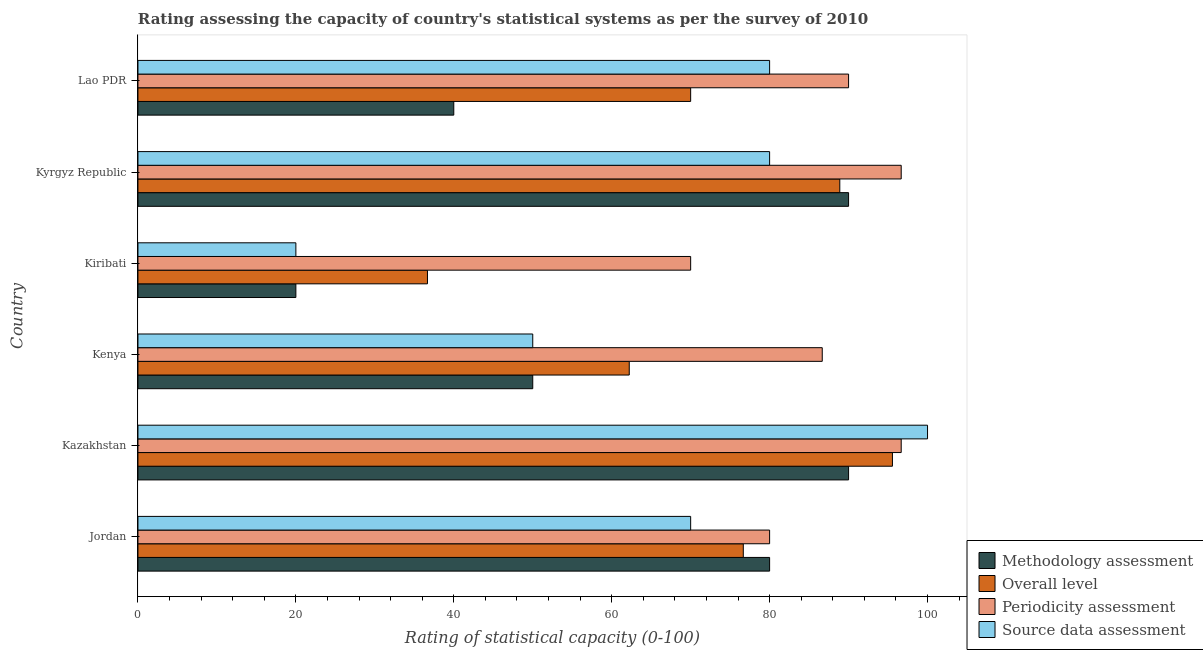How many groups of bars are there?
Give a very brief answer. 6. Are the number of bars per tick equal to the number of legend labels?
Your response must be concise. Yes. Are the number of bars on each tick of the Y-axis equal?
Provide a short and direct response. Yes. How many bars are there on the 6th tick from the bottom?
Your response must be concise. 4. What is the label of the 4th group of bars from the top?
Provide a short and direct response. Kenya. In how many cases, is the number of bars for a given country not equal to the number of legend labels?
Provide a succinct answer. 0. What is the overall level rating in Kenya?
Offer a very short reply. 62.22. Across all countries, what is the maximum overall level rating?
Your answer should be very brief. 95.56. Across all countries, what is the minimum methodology assessment rating?
Provide a succinct answer. 20. In which country was the methodology assessment rating maximum?
Your response must be concise. Kazakhstan. In which country was the source data assessment rating minimum?
Offer a terse response. Kiribati. What is the total periodicity assessment rating in the graph?
Offer a terse response. 520. What is the difference between the periodicity assessment rating in Kiribati and that in Kyrgyz Republic?
Make the answer very short. -26.67. What is the difference between the periodicity assessment rating in Kenya and the source data assessment rating in Kiribati?
Make the answer very short. 66.67. What is the average periodicity assessment rating per country?
Ensure brevity in your answer.  86.67. In how many countries, is the methodology assessment rating greater than 68 ?
Provide a succinct answer. 3. What is the ratio of the methodology assessment rating in Jordan to that in Lao PDR?
Keep it short and to the point. 2. Is the source data assessment rating in Kiribati less than that in Lao PDR?
Offer a terse response. Yes. Is the difference between the source data assessment rating in Jordan and Kiribati greater than the difference between the periodicity assessment rating in Jordan and Kiribati?
Ensure brevity in your answer.  Yes. What is the difference between the highest and the second highest methodology assessment rating?
Give a very brief answer. 0. What is the difference between the highest and the lowest methodology assessment rating?
Your response must be concise. 70. In how many countries, is the methodology assessment rating greater than the average methodology assessment rating taken over all countries?
Make the answer very short. 3. Is it the case that in every country, the sum of the methodology assessment rating and source data assessment rating is greater than the sum of periodicity assessment rating and overall level rating?
Provide a succinct answer. No. What does the 4th bar from the top in Kazakhstan represents?
Your response must be concise. Methodology assessment. What does the 4th bar from the bottom in Kenya represents?
Make the answer very short. Source data assessment. Is it the case that in every country, the sum of the methodology assessment rating and overall level rating is greater than the periodicity assessment rating?
Keep it short and to the point. No. How many bars are there?
Your answer should be very brief. 24. Are all the bars in the graph horizontal?
Offer a very short reply. Yes. How many countries are there in the graph?
Provide a short and direct response. 6. Where does the legend appear in the graph?
Offer a terse response. Bottom right. How many legend labels are there?
Provide a short and direct response. 4. How are the legend labels stacked?
Give a very brief answer. Vertical. What is the title of the graph?
Keep it short and to the point. Rating assessing the capacity of country's statistical systems as per the survey of 2010 . Does "Primary schools" appear as one of the legend labels in the graph?
Provide a succinct answer. No. What is the label or title of the X-axis?
Give a very brief answer. Rating of statistical capacity (0-100). What is the label or title of the Y-axis?
Your answer should be compact. Country. What is the Rating of statistical capacity (0-100) in Methodology assessment in Jordan?
Provide a succinct answer. 80. What is the Rating of statistical capacity (0-100) in Overall level in Jordan?
Your answer should be compact. 76.67. What is the Rating of statistical capacity (0-100) in Periodicity assessment in Jordan?
Keep it short and to the point. 80. What is the Rating of statistical capacity (0-100) in Source data assessment in Jordan?
Provide a short and direct response. 70. What is the Rating of statistical capacity (0-100) in Methodology assessment in Kazakhstan?
Offer a very short reply. 90. What is the Rating of statistical capacity (0-100) in Overall level in Kazakhstan?
Keep it short and to the point. 95.56. What is the Rating of statistical capacity (0-100) of Periodicity assessment in Kazakhstan?
Give a very brief answer. 96.67. What is the Rating of statistical capacity (0-100) in Overall level in Kenya?
Give a very brief answer. 62.22. What is the Rating of statistical capacity (0-100) of Periodicity assessment in Kenya?
Provide a succinct answer. 86.67. What is the Rating of statistical capacity (0-100) of Overall level in Kiribati?
Ensure brevity in your answer.  36.67. What is the Rating of statistical capacity (0-100) in Periodicity assessment in Kiribati?
Provide a succinct answer. 70. What is the Rating of statistical capacity (0-100) in Methodology assessment in Kyrgyz Republic?
Keep it short and to the point. 90. What is the Rating of statistical capacity (0-100) in Overall level in Kyrgyz Republic?
Offer a terse response. 88.89. What is the Rating of statistical capacity (0-100) of Periodicity assessment in Kyrgyz Republic?
Make the answer very short. 96.67. What is the Rating of statistical capacity (0-100) of Overall level in Lao PDR?
Make the answer very short. 70. What is the Rating of statistical capacity (0-100) in Periodicity assessment in Lao PDR?
Offer a terse response. 90. Across all countries, what is the maximum Rating of statistical capacity (0-100) of Methodology assessment?
Your answer should be compact. 90. Across all countries, what is the maximum Rating of statistical capacity (0-100) of Overall level?
Offer a terse response. 95.56. Across all countries, what is the maximum Rating of statistical capacity (0-100) of Periodicity assessment?
Give a very brief answer. 96.67. Across all countries, what is the maximum Rating of statistical capacity (0-100) in Source data assessment?
Keep it short and to the point. 100. Across all countries, what is the minimum Rating of statistical capacity (0-100) in Overall level?
Ensure brevity in your answer.  36.67. Across all countries, what is the minimum Rating of statistical capacity (0-100) of Source data assessment?
Your answer should be compact. 20. What is the total Rating of statistical capacity (0-100) of Methodology assessment in the graph?
Make the answer very short. 370. What is the total Rating of statistical capacity (0-100) of Overall level in the graph?
Your response must be concise. 430. What is the total Rating of statistical capacity (0-100) in Periodicity assessment in the graph?
Offer a very short reply. 520. What is the total Rating of statistical capacity (0-100) of Source data assessment in the graph?
Give a very brief answer. 400. What is the difference between the Rating of statistical capacity (0-100) in Overall level in Jordan and that in Kazakhstan?
Provide a short and direct response. -18.89. What is the difference between the Rating of statistical capacity (0-100) of Periodicity assessment in Jordan and that in Kazakhstan?
Provide a short and direct response. -16.67. What is the difference between the Rating of statistical capacity (0-100) of Source data assessment in Jordan and that in Kazakhstan?
Provide a succinct answer. -30. What is the difference between the Rating of statistical capacity (0-100) in Overall level in Jordan and that in Kenya?
Keep it short and to the point. 14.44. What is the difference between the Rating of statistical capacity (0-100) of Periodicity assessment in Jordan and that in Kenya?
Your answer should be very brief. -6.67. What is the difference between the Rating of statistical capacity (0-100) in Source data assessment in Jordan and that in Kenya?
Offer a very short reply. 20. What is the difference between the Rating of statistical capacity (0-100) in Overall level in Jordan and that in Kyrgyz Republic?
Provide a short and direct response. -12.22. What is the difference between the Rating of statistical capacity (0-100) in Periodicity assessment in Jordan and that in Kyrgyz Republic?
Your answer should be very brief. -16.67. What is the difference between the Rating of statistical capacity (0-100) in Source data assessment in Jordan and that in Kyrgyz Republic?
Ensure brevity in your answer.  -10. What is the difference between the Rating of statistical capacity (0-100) of Source data assessment in Jordan and that in Lao PDR?
Your answer should be compact. -10. What is the difference between the Rating of statistical capacity (0-100) in Overall level in Kazakhstan and that in Kenya?
Your response must be concise. 33.33. What is the difference between the Rating of statistical capacity (0-100) in Overall level in Kazakhstan and that in Kiribati?
Ensure brevity in your answer.  58.89. What is the difference between the Rating of statistical capacity (0-100) in Periodicity assessment in Kazakhstan and that in Kiribati?
Keep it short and to the point. 26.67. What is the difference between the Rating of statistical capacity (0-100) in Methodology assessment in Kazakhstan and that in Kyrgyz Republic?
Keep it short and to the point. 0. What is the difference between the Rating of statistical capacity (0-100) of Overall level in Kazakhstan and that in Lao PDR?
Your response must be concise. 25.56. What is the difference between the Rating of statistical capacity (0-100) of Source data assessment in Kazakhstan and that in Lao PDR?
Your answer should be very brief. 20. What is the difference between the Rating of statistical capacity (0-100) in Overall level in Kenya and that in Kiribati?
Provide a succinct answer. 25.56. What is the difference between the Rating of statistical capacity (0-100) of Periodicity assessment in Kenya and that in Kiribati?
Offer a terse response. 16.67. What is the difference between the Rating of statistical capacity (0-100) of Overall level in Kenya and that in Kyrgyz Republic?
Your answer should be very brief. -26.67. What is the difference between the Rating of statistical capacity (0-100) of Periodicity assessment in Kenya and that in Kyrgyz Republic?
Your response must be concise. -10. What is the difference between the Rating of statistical capacity (0-100) in Source data assessment in Kenya and that in Kyrgyz Republic?
Offer a very short reply. -30. What is the difference between the Rating of statistical capacity (0-100) in Overall level in Kenya and that in Lao PDR?
Offer a terse response. -7.78. What is the difference between the Rating of statistical capacity (0-100) of Source data assessment in Kenya and that in Lao PDR?
Your answer should be very brief. -30. What is the difference between the Rating of statistical capacity (0-100) in Methodology assessment in Kiribati and that in Kyrgyz Republic?
Provide a succinct answer. -70. What is the difference between the Rating of statistical capacity (0-100) of Overall level in Kiribati and that in Kyrgyz Republic?
Make the answer very short. -52.22. What is the difference between the Rating of statistical capacity (0-100) of Periodicity assessment in Kiribati and that in Kyrgyz Republic?
Provide a succinct answer. -26.67. What is the difference between the Rating of statistical capacity (0-100) in Source data assessment in Kiribati and that in Kyrgyz Republic?
Make the answer very short. -60. What is the difference between the Rating of statistical capacity (0-100) of Methodology assessment in Kiribati and that in Lao PDR?
Provide a short and direct response. -20. What is the difference between the Rating of statistical capacity (0-100) of Overall level in Kiribati and that in Lao PDR?
Make the answer very short. -33.33. What is the difference between the Rating of statistical capacity (0-100) in Source data assessment in Kiribati and that in Lao PDR?
Make the answer very short. -60. What is the difference between the Rating of statistical capacity (0-100) in Methodology assessment in Kyrgyz Republic and that in Lao PDR?
Provide a succinct answer. 50. What is the difference between the Rating of statistical capacity (0-100) of Overall level in Kyrgyz Republic and that in Lao PDR?
Your response must be concise. 18.89. What is the difference between the Rating of statistical capacity (0-100) of Source data assessment in Kyrgyz Republic and that in Lao PDR?
Give a very brief answer. 0. What is the difference between the Rating of statistical capacity (0-100) of Methodology assessment in Jordan and the Rating of statistical capacity (0-100) of Overall level in Kazakhstan?
Ensure brevity in your answer.  -15.56. What is the difference between the Rating of statistical capacity (0-100) in Methodology assessment in Jordan and the Rating of statistical capacity (0-100) in Periodicity assessment in Kazakhstan?
Your response must be concise. -16.67. What is the difference between the Rating of statistical capacity (0-100) in Methodology assessment in Jordan and the Rating of statistical capacity (0-100) in Source data assessment in Kazakhstan?
Keep it short and to the point. -20. What is the difference between the Rating of statistical capacity (0-100) of Overall level in Jordan and the Rating of statistical capacity (0-100) of Source data assessment in Kazakhstan?
Provide a short and direct response. -23.33. What is the difference between the Rating of statistical capacity (0-100) of Periodicity assessment in Jordan and the Rating of statistical capacity (0-100) of Source data assessment in Kazakhstan?
Keep it short and to the point. -20. What is the difference between the Rating of statistical capacity (0-100) in Methodology assessment in Jordan and the Rating of statistical capacity (0-100) in Overall level in Kenya?
Your answer should be very brief. 17.78. What is the difference between the Rating of statistical capacity (0-100) in Methodology assessment in Jordan and the Rating of statistical capacity (0-100) in Periodicity assessment in Kenya?
Your answer should be very brief. -6.67. What is the difference between the Rating of statistical capacity (0-100) in Overall level in Jordan and the Rating of statistical capacity (0-100) in Source data assessment in Kenya?
Your answer should be very brief. 26.67. What is the difference between the Rating of statistical capacity (0-100) of Periodicity assessment in Jordan and the Rating of statistical capacity (0-100) of Source data assessment in Kenya?
Give a very brief answer. 30. What is the difference between the Rating of statistical capacity (0-100) in Methodology assessment in Jordan and the Rating of statistical capacity (0-100) in Overall level in Kiribati?
Offer a very short reply. 43.33. What is the difference between the Rating of statistical capacity (0-100) of Methodology assessment in Jordan and the Rating of statistical capacity (0-100) of Periodicity assessment in Kiribati?
Provide a short and direct response. 10. What is the difference between the Rating of statistical capacity (0-100) of Overall level in Jordan and the Rating of statistical capacity (0-100) of Source data assessment in Kiribati?
Make the answer very short. 56.67. What is the difference between the Rating of statistical capacity (0-100) in Methodology assessment in Jordan and the Rating of statistical capacity (0-100) in Overall level in Kyrgyz Republic?
Make the answer very short. -8.89. What is the difference between the Rating of statistical capacity (0-100) in Methodology assessment in Jordan and the Rating of statistical capacity (0-100) in Periodicity assessment in Kyrgyz Republic?
Your answer should be compact. -16.67. What is the difference between the Rating of statistical capacity (0-100) in Methodology assessment in Jordan and the Rating of statistical capacity (0-100) in Source data assessment in Kyrgyz Republic?
Your answer should be very brief. 0. What is the difference between the Rating of statistical capacity (0-100) in Overall level in Jordan and the Rating of statistical capacity (0-100) in Periodicity assessment in Kyrgyz Republic?
Offer a very short reply. -20. What is the difference between the Rating of statistical capacity (0-100) in Periodicity assessment in Jordan and the Rating of statistical capacity (0-100) in Source data assessment in Kyrgyz Republic?
Keep it short and to the point. 0. What is the difference between the Rating of statistical capacity (0-100) in Methodology assessment in Jordan and the Rating of statistical capacity (0-100) in Source data assessment in Lao PDR?
Your answer should be compact. 0. What is the difference between the Rating of statistical capacity (0-100) in Overall level in Jordan and the Rating of statistical capacity (0-100) in Periodicity assessment in Lao PDR?
Provide a succinct answer. -13.33. What is the difference between the Rating of statistical capacity (0-100) in Overall level in Jordan and the Rating of statistical capacity (0-100) in Source data assessment in Lao PDR?
Provide a short and direct response. -3.33. What is the difference between the Rating of statistical capacity (0-100) of Methodology assessment in Kazakhstan and the Rating of statistical capacity (0-100) of Overall level in Kenya?
Make the answer very short. 27.78. What is the difference between the Rating of statistical capacity (0-100) in Methodology assessment in Kazakhstan and the Rating of statistical capacity (0-100) in Periodicity assessment in Kenya?
Your answer should be very brief. 3.33. What is the difference between the Rating of statistical capacity (0-100) in Overall level in Kazakhstan and the Rating of statistical capacity (0-100) in Periodicity assessment in Kenya?
Provide a succinct answer. 8.89. What is the difference between the Rating of statistical capacity (0-100) in Overall level in Kazakhstan and the Rating of statistical capacity (0-100) in Source data assessment in Kenya?
Your answer should be very brief. 45.56. What is the difference between the Rating of statistical capacity (0-100) of Periodicity assessment in Kazakhstan and the Rating of statistical capacity (0-100) of Source data assessment in Kenya?
Make the answer very short. 46.67. What is the difference between the Rating of statistical capacity (0-100) in Methodology assessment in Kazakhstan and the Rating of statistical capacity (0-100) in Overall level in Kiribati?
Your answer should be compact. 53.33. What is the difference between the Rating of statistical capacity (0-100) of Overall level in Kazakhstan and the Rating of statistical capacity (0-100) of Periodicity assessment in Kiribati?
Offer a very short reply. 25.56. What is the difference between the Rating of statistical capacity (0-100) in Overall level in Kazakhstan and the Rating of statistical capacity (0-100) in Source data assessment in Kiribati?
Offer a terse response. 75.56. What is the difference between the Rating of statistical capacity (0-100) in Periodicity assessment in Kazakhstan and the Rating of statistical capacity (0-100) in Source data assessment in Kiribati?
Keep it short and to the point. 76.67. What is the difference between the Rating of statistical capacity (0-100) of Methodology assessment in Kazakhstan and the Rating of statistical capacity (0-100) of Periodicity assessment in Kyrgyz Republic?
Your answer should be compact. -6.67. What is the difference between the Rating of statistical capacity (0-100) in Methodology assessment in Kazakhstan and the Rating of statistical capacity (0-100) in Source data assessment in Kyrgyz Republic?
Your answer should be compact. 10. What is the difference between the Rating of statistical capacity (0-100) in Overall level in Kazakhstan and the Rating of statistical capacity (0-100) in Periodicity assessment in Kyrgyz Republic?
Offer a very short reply. -1.11. What is the difference between the Rating of statistical capacity (0-100) of Overall level in Kazakhstan and the Rating of statistical capacity (0-100) of Source data assessment in Kyrgyz Republic?
Give a very brief answer. 15.56. What is the difference between the Rating of statistical capacity (0-100) of Periodicity assessment in Kazakhstan and the Rating of statistical capacity (0-100) of Source data assessment in Kyrgyz Republic?
Provide a short and direct response. 16.67. What is the difference between the Rating of statistical capacity (0-100) in Overall level in Kazakhstan and the Rating of statistical capacity (0-100) in Periodicity assessment in Lao PDR?
Your response must be concise. 5.56. What is the difference between the Rating of statistical capacity (0-100) in Overall level in Kazakhstan and the Rating of statistical capacity (0-100) in Source data assessment in Lao PDR?
Offer a terse response. 15.56. What is the difference between the Rating of statistical capacity (0-100) in Periodicity assessment in Kazakhstan and the Rating of statistical capacity (0-100) in Source data assessment in Lao PDR?
Your response must be concise. 16.67. What is the difference between the Rating of statistical capacity (0-100) of Methodology assessment in Kenya and the Rating of statistical capacity (0-100) of Overall level in Kiribati?
Your answer should be very brief. 13.33. What is the difference between the Rating of statistical capacity (0-100) of Methodology assessment in Kenya and the Rating of statistical capacity (0-100) of Periodicity assessment in Kiribati?
Offer a terse response. -20. What is the difference between the Rating of statistical capacity (0-100) in Methodology assessment in Kenya and the Rating of statistical capacity (0-100) in Source data assessment in Kiribati?
Give a very brief answer. 30. What is the difference between the Rating of statistical capacity (0-100) in Overall level in Kenya and the Rating of statistical capacity (0-100) in Periodicity assessment in Kiribati?
Provide a succinct answer. -7.78. What is the difference between the Rating of statistical capacity (0-100) of Overall level in Kenya and the Rating of statistical capacity (0-100) of Source data assessment in Kiribati?
Ensure brevity in your answer.  42.22. What is the difference between the Rating of statistical capacity (0-100) in Periodicity assessment in Kenya and the Rating of statistical capacity (0-100) in Source data assessment in Kiribati?
Your answer should be compact. 66.67. What is the difference between the Rating of statistical capacity (0-100) in Methodology assessment in Kenya and the Rating of statistical capacity (0-100) in Overall level in Kyrgyz Republic?
Provide a short and direct response. -38.89. What is the difference between the Rating of statistical capacity (0-100) in Methodology assessment in Kenya and the Rating of statistical capacity (0-100) in Periodicity assessment in Kyrgyz Republic?
Provide a succinct answer. -46.67. What is the difference between the Rating of statistical capacity (0-100) of Overall level in Kenya and the Rating of statistical capacity (0-100) of Periodicity assessment in Kyrgyz Republic?
Provide a succinct answer. -34.44. What is the difference between the Rating of statistical capacity (0-100) of Overall level in Kenya and the Rating of statistical capacity (0-100) of Source data assessment in Kyrgyz Republic?
Offer a very short reply. -17.78. What is the difference between the Rating of statistical capacity (0-100) in Methodology assessment in Kenya and the Rating of statistical capacity (0-100) in Overall level in Lao PDR?
Offer a very short reply. -20. What is the difference between the Rating of statistical capacity (0-100) of Overall level in Kenya and the Rating of statistical capacity (0-100) of Periodicity assessment in Lao PDR?
Your answer should be very brief. -27.78. What is the difference between the Rating of statistical capacity (0-100) of Overall level in Kenya and the Rating of statistical capacity (0-100) of Source data assessment in Lao PDR?
Provide a short and direct response. -17.78. What is the difference between the Rating of statistical capacity (0-100) of Methodology assessment in Kiribati and the Rating of statistical capacity (0-100) of Overall level in Kyrgyz Republic?
Your answer should be very brief. -68.89. What is the difference between the Rating of statistical capacity (0-100) of Methodology assessment in Kiribati and the Rating of statistical capacity (0-100) of Periodicity assessment in Kyrgyz Republic?
Your answer should be compact. -76.67. What is the difference between the Rating of statistical capacity (0-100) of Methodology assessment in Kiribati and the Rating of statistical capacity (0-100) of Source data assessment in Kyrgyz Republic?
Keep it short and to the point. -60. What is the difference between the Rating of statistical capacity (0-100) in Overall level in Kiribati and the Rating of statistical capacity (0-100) in Periodicity assessment in Kyrgyz Republic?
Provide a succinct answer. -60. What is the difference between the Rating of statistical capacity (0-100) of Overall level in Kiribati and the Rating of statistical capacity (0-100) of Source data assessment in Kyrgyz Republic?
Give a very brief answer. -43.33. What is the difference between the Rating of statistical capacity (0-100) in Periodicity assessment in Kiribati and the Rating of statistical capacity (0-100) in Source data assessment in Kyrgyz Republic?
Ensure brevity in your answer.  -10. What is the difference between the Rating of statistical capacity (0-100) of Methodology assessment in Kiribati and the Rating of statistical capacity (0-100) of Overall level in Lao PDR?
Your response must be concise. -50. What is the difference between the Rating of statistical capacity (0-100) of Methodology assessment in Kiribati and the Rating of statistical capacity (0-100) of Periodicity assessment in Lao PDR?
Make the answer very short. -70. What is the difference between the Rating of statistical capacity (0-100) in Methodology assessment in Kiribati and the Rating of statistical capacity (0-100) in Source data assessment in Lao PDR?
Give a very brief answer. -60. What is the difference between the Rating of statistical capacity (0-100) of Overall level in Kiribati and the Rating of statistical capacity (0-100) of Periodicity assessment in Lao PDR?
Provide a succinct answer. -53.33. What is the difference between the Rating of statistical capacity (0-100) in Overall level in Kiribati and the Rating of statistical capacity (0-100) in Source data assessment in Lao PDR?
Provide a succinct answer. -43.33. What is the difference between the Rating of statistical capacity (0-100) in Methodology assessment in Kyrgyz Republic and the Rating of statistical capacity (0-100) in Source data assessment in Lao PDR?
Offer a terse response. 10. What is the difference between the Rating of statistical capacity (0-100) in Overall level in Kyrgyz Republic and the Rating of statistical capacity (0-100) in Periodicity assessment in Lao PDR?
Offer a very short reply. -1.11. What is the difference between the Rating of statistical capacity (0-100) in Overall level in Kyrgyz Republic and the Rating of statistical capacity (0-100) in Source data assessment in Lao PDR?
Offer a very short reply. 8.89. What is the difference between the Rating of statistical capacity (0-100) in Periodicity assessment in Kyrgyz Republic and the Rating of statistical capacity (0-100) in Source data assessment in Lao PDR?
Provide a succinct answer. 16.67. What is the average Rating of statistical capacity (0-100) of Methodology assessment per country?
Ensure brevity in your answer.  61.67. What is the average Rating of statistical capacity (0-100) of Overall level per country?
Provide a short and direct response. 71.67. What is the average Rating of statistical capacity (0-100) in Periodicity assessment per country?
Provide a short and direct response. 86.67. What is the average Rating of statistical capacity (0-100) of Source data assessment per country?
Give a very brief answer. 66.67. What is the difference between the Rating of statistical capacity (0-100) of Methodology assessment and Rating of statistical capacity (0-100) of Periodicity assessment in Jordan?
Provide a succinct answer. 0. What is the difference between the Rating of statistical capacity (0-100) of Methodology assessment and Rating of statistical capacity (0-100) of Source data assessment in Jordan?
Keep it short and to the point. 10. What is the difference between the Rating of statistical capacity (0-100) of Overall level and Rating of statistical capacity (0-100) of Periodicity assessment in Jordan?
Keep it short and to the point. -3.33. What is the difference between the Rating of statistical capacity (0-100) of Methodology assessment and Rating of statistical capacity (0-100) of Overall level in Kazakhstan?
Provide a succinct answer. -5.56. What is the difference between the Rating of statistical capacity (0-100) of Methodology assessment and Rating of statistical capacity (0-100) of Periodicity assessment in Kazakhstan?
Keep it short and to the point. -6.67. What is the difference between the Rating of statistical capacity (0-100) in Methodology assessment and Rating of statistical capacity (0-100) in Source data assessment in Kazakhstan?
Offer a terse response. -10. What is the difference between the Rating of statistical capacity (0-100) of Overall level and Rating of statistical capacity (0-100) of Periodicity assessment in Kazakhstan?
Provide a short and direct response. -1.11. What is the difference between the Rating of statistical capacity (0-100) of Overall level and Rating of statistical capacity (0-100) of Source data assessment in Kazakhstan?
Provide a succinct answer. -4.44. What is the difference between the Rating of statistical capacity (0-100) in Periodicity assessment and Rating of statistical capacity (0-100) in Source data assessment in Kazakhstan?
Ensure brevity in your answer.  -3.33. What is the difference between the Rating of statistical capacity (0-100) of Methodology assessment and Rating of statistical capacity (0-100) of Overall level in Kenya?
Offer a terse response. -12.22. What is the difference between the Rating of statistical capacity (0-100) in Methodology assessment and Rating of statistical capacity (0-100) in Periodicity assessment in Kenya?
Provide a succinct answer. -36.67. What is the difference between the Rating of statistical capacity (0-100) of Overall level and Rating of statistical capacity (0-100) of Periodicity assessment in Kenya?
Offer a very short reply. -24.44. What is the difference between the Rating of statistical capacity (0-100) of Overall level and Rating of statistical capacity (0-100) of Source data assessment in Kenya?
Ensure brevity in your answer.  12.22. What is the difference between the Rating of statistical capacity (0-100) in Periodicity assessment and Rating of statistical capacity (0-100) in Source data assessment in Kenya?
Make the answer very short. 36.67. What is the difference between the Rating of statistical capacity (0-100) in Methodology assessment and Rating of statistical capacity (0-100) in Overall level in Kiribati?
Provide a succinct answer. -16.67. What is the difference between the Rating of statistical capacity (0-100) of Methodology assessment and Rating of statistical capacity (0-100) of Periodicity assessment in Kiribati?
Your answer should be very brief. -50. What is the difference between the Rating of statistical capacity (0-100) of Methodology assessment and Rating of statistical capacity (0-100) of Source data assessment in Kiribati?
Provide a succinct answer. 0. What is the difference between the Rating of statistical capacity (0-100) of Overall level and Rating of statistical capacity (0-100) of Periodicity assessment in Kiribati?
Offer a very short reply. -33.33. What is the difference between the Rating of statistical capacity (0-100) in Overall level and Rating of statistical capacity (0-100) in Source data assessment in Kiribati?
Offer a terse response. 16.67. What is the difference between the Rating of statistical capacity (0-100) in Periodicity assessment and Rating of statistical capacity (0-100) in Source data assessment in Kiribati?
Your answer should be compact. 50. What is the difference between the Rating of statistical capacity (0-100) of Methodology assessment and Rating of statistical capacity (0-100) of Periodicity assessment in Kyrgyz Republic?
Offer a very short reply. -6.67. What is the difference between the Rating of statistical capacity (0-100) in Methodology assessment and Rating of statistical capacity (0-100) in Source data assessment in Kyrgyz Republic?
Keep it short and to the point. 10. What is the difference between the Rating of statistical capacity (0-100) of Overall level and Rating of statistical capacity (0-100) of Periodicity assessment in Kyrgyz Republic?
Give a very brief answer. -7.78. What is the difference between the Rating of statistical capacity (0-100) of Overall level and Rating of statistical capacity (0-100) of Source data assessment in Kyrgyz Republic?
Your response must be concise. 8.89. What is the difference between the Rating of statistical capacity (0-100) of Periodicity assessment and Rating of statistical capacity (0-100) of Source data assessment in Kyrgyz Republic?
Provide a short and direct response. 16.67. What is the difference between the Rating of statistical capacity (0-100) of Overall level and Rating of statistical capacity (0-100) of Periodicity assessment in Lao PDR?
Make the answer very short. -20. What is the difference between the Rating of statistical capacity (0-100) of Overall level and Rating of statistical capacity (0-100) of Source data assessment in Lao PDR?
Give a very brief answer. -10. What is the ratio of the Rating of statistical capacity (0-100) of Methodology assessment in Jordan to that in Kazakhstan?
Ensure brevity in your answer.  0.89. What is the ratio of the Rating of statistical capacity (0-100) in Overall level in Jordan to that in Kazakhstan?
Your answer should be very brief. 0.8. What is the ratio of the Rating of statistical capacity (0-100) in Periodicity assessment in Jordan to that in Kazakhstan?
Offer a very short reply. 0.83. What is the ratio of the Rating of statistical capacity (0-100) of Source data assessment in Jordan to that in Kazakhstan?
Give a very brief answer. 0.7. What is the ratio of the Rating of statistical capacity (0-100) of Methodology assessment in Jordan to that in Kenya?
Provide a succinct answer. 1.6. What is the ratio of the Rating of statistical capacity (0-100) in Overall level in Jordan to that in Kenya?
Your response must be concise. 1.23. What is the ratio of the Rating of statistical capacity (0-100) in Source data assessment in Jordan to that in Kenya?
Keep it short and to the point. 1.4. What is the ratio of the Rating of statistical capacity (0-100) of Overall level in Jordan to that in Kiribati?
Ensure brevity in your answer.  2.09. What is the ratio of the Rating of statistical capacity (0-100) of Overall level in Jordan to that in Kyrgyz Republic?
Provide a succinct answer. 0.86. What is the ratio of the Rating of statistical capacity (0-100) in Periodicity assessment in Jordan to that in Kyrgyz Republic?
Offer a terse response. 0.83. What is the ratio of the Rating of statistical capacity (0-100) in Source data assessment in Jordan to that in Kyrgyz Republic?
Offer a terse response. 0.88. What is the ratio of the Rating of statistical capacity (0-100) of Overall level in Jordan to that in Lao PDR?
Your answer should be very brief. 1.1. What is the ratio of the Rating of statistical capacity (0-100) in Source data assessment in Jordan to that in Lao PDR?
Offer a terse response. 0.88. What is the ratio of the Rating of statistical capacity (0-100) in Overall level in Kazakhstan to that in Kenya?
Make the answer very short. 1.54. What is the ratio of the Rating of statistical capacity (0-100) of Periodicity assessment in Kazakhstan to that in Kenya?
Give a very brief answer. 1.12. What is the ratio of the Rating of statistical capacity (0-100) of Methodology assessment in Kazakhstan to that in Kiribati?
Provide a short and direct response. 4.5. What is the ratio of the Rating of statistical capacity (0-100) in Overall level in Kazakhstan to that in Kiribati?
Your answer should be compact. 2.61. What is the ratio of the Rating of statistical capacity (0-100) in Periodicity assessment in Kazakhstan to that in Kiribati?
Your answer should be very brief. 1.38. What is the ratio of the Rating of statistical capacity (0-100) of Methodology assessment in Kazakhstan to that in Kyrgyz Republic?
Your answer should be very brief. 1. What is the ratio of the Rating of statistical capacity (0-100) of Overall level in Kazakhstan to that in Kyrgyz Republic?
Provide a succinct answer. 1.07. What is the ratio of the Rating of statistical capacity (0-100) of Periodicity assessment in Kazakhstan to that in Kyrgyz Republic?
Keep it short and to the point. 1. What is the ratio of the Rating of statistical capacity (0-100) in Source data assessment in Kazakhstan to that in Kyrgyz Republic?
Ensure brevity in your answer.  1.25. What is the ratio of the Rating of statistical capacity (0-100) of Methodology assessment in Kazakhstan to that in Lao PDR?
Your answer should be very brief. 2.25. What is the ratio of the Rating of statistical capacity (0-100) of Overall level in Kazakhstan to that in Lao PDR?
Your answer should be compact. 1.37. What is the ratio of the Rating of statistical capacity (0-100) of Periodicity assessment in Kazakhstan to that in Lao PDR?
Keep it short and to the point. 1.07. What is the ratio of the Rating of statistical capacity (0-100) of Overall level in Kenya to that in Kiribati?
Give a very brief answer. 1.7. What is the ratio of the Rating of statistical capacity (0-100) in Periodicity assessment in Kenya to that in Kiribati?
Your answer should be very brief. 1.24. What is the ratio of the Rating of statistical capacity (0-100) in Source data assessment in Kenya to that in Kiribati?
Provide a succinct answer. 2.5. What is the ratio of the Rating of statistical capacity (0-100) of Methodology assessment in Kenya to that in Kyrgyz Republic?
Make the answer very short. 0.56. What is the ratio of the Rating of statistical capacity (0-100) in Periodicity assessment in Kenya to that in Kyrgyz Republic?
Provide a succinct answer. 0.9. What is the ratio of the Rating of statistical capacity (0-100) of Methodology assessment in Kenya to that in Lao PDR?
Ensure brevity in your answer.  1.25. What is the ratio of the Rating of statistical capacity (0-100) in Overall level in Kenya to that in Lao PDR?
Offer a terse response. 0.89. What is the ratio of the Rating of statistical capacity (0-100) in Periodicity assessment in Kenya to that in Lao PDR?
Give a very brief answer. 0.96. What is the ratio of the Rating of statistical capacity (0-100) of Methodology assessment in Kiribati to that in Kyrgyz Republic?
Make the answer very short. 0.22. What is the ratio of the Rating of statistical capacity (0-100) of Overall level in Kiribati to that in Kyrgyz Republic?
Keep it short and to the point. 0.41. What is the ratio of the Rating of statistical capacity (0-100) in Periodicity assessment in Kiribati to that in Kyrgyz Republic?
Your answer should be compact. 0.72. What is the ratio of the Rating of statistical capacity (0-100) of Source data assessment in Kiribati to that in Kyrgyz Republic?
Your answer should be very brief. 0.25. What is the ratio of the Rating of statistical capacity (0-100) in Overall level in Kiribati to that in Lao PDR?
Keep it short and to the point. 0.52. What is the ratio of the Rating of statistical capacity (0-100) of Methodology assessment in Kyrgyz Republic to that in Lao PDR?
Your response must be concise. 2.25. What is the ratio of the Rating of statistical capacity (0-100) in Overall level in Kyrgyz Republic to that in Lao PDR?
Offer a very short reply. 1.27. What is the ratio of the Rating of statistical capacity (0-100) of Periodicity assessment in Kyrgyz Republic to that in Lao PDR?
Your response must be concise. 1.07. What is the ratio of the Rating of statistical capacity (0-100) in Source data assessment in Kyrgyz Republic to that in Lao PDR?
Ensure brevity in your answer.  1. What is the difference between the highest and the second highest Rating of statistical capacity (0-100) of Periodicity assessment?
Provide a short and direct response. 0. What is the difference between the highest and the second highest Rating of statistical capacity (0-100) in Source data assessment?
Ensure brevity in your answer.  20. What is the difference between the highest and the lowest Rating of statistical capacity (0-100) in Methodology assessment?
Keep it short and to the point. 70. What is the difference between the highest and the lowest Rating of statistical capacity (0-100) of Overall level?
Keep it short and to the point. 58.89. What is the difference between the highest and the lowest Rating of statistical capacity (0-100) of Periodicity assessment?
Offer a very short reply. 26.67. What is the difference between the highest and the lowest Rating of statistical capacity (0-100) of Source data assessment?
Offer a terse response. 80. 